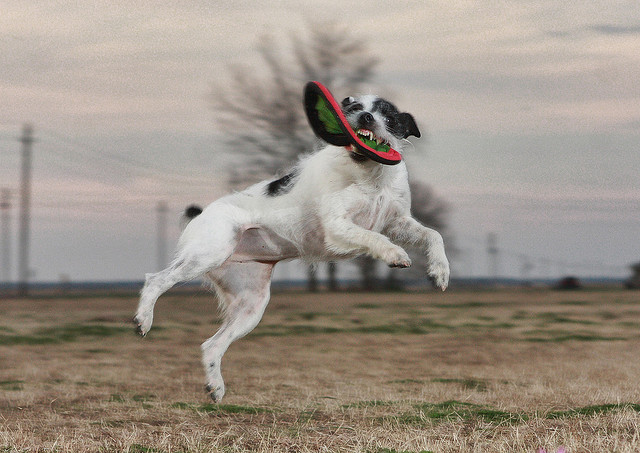What time of day does this photo seem to be taken at? The photo seems to be taken around dusk or dawn, given the soft, diffused light and the long shadows cast onto the field, suggesting the sun is low on the horizon. Does this time of day have any specific advantages for photography? Yes, the time around sunrise and sunset, often referred to as the 'golden hour,' is prized by photographers for the warm and soft quality of light, which can add a beautiful glow to images and create dramatic shadows. 